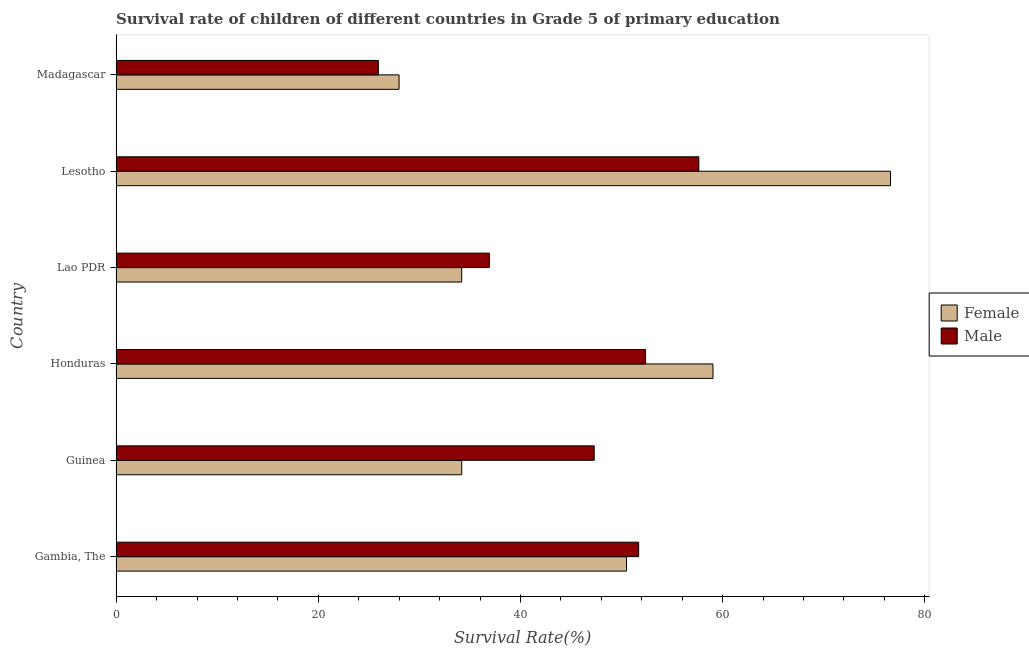How many different coloured bars are there?
Keep it short and to the point. 2. How many groups of bars are there?
Provide a succinct answer. 6. Are the number of bars on each tick of the Y-axis equal?
Give a very brief answer. Yes. What is the label of the 2nd group of bars from the top?
Keep it short and to the point. Lesotho. What is the survival rate of male students in primary education in Guinea?
Make the answer very short. 47.29. Across all countries, what is the maximum survival rate of female students in primary education?
Give a very brief answer. 76.6. Across all countries, what is the minimum survival rate of male students in primary education?
Provide a succinct answer. 25.94. In which country was the survival rate of male students in primary education maximum?
Make the answer very short. Lesotho. In which country was the survival rate of male students in primary education minimum?
Keep it short and to the point. Madagascar. What is the total survival rate of male students in primary education in the graph?
Keep it short and to the point. 271.85. What is the difference between the survival rate of male students in primary education in Gambia, The and that in Guinea?
Offer a terse response. 4.4. What is the difference between the survival rate of male students in primary education in Honduras and the survival rate of female students in primary education in Madagascar?
Ensure brevity in your answer.  24.38. What is the average survival rate of female students in primary education per country?
Offer a very short reply. 47.08. What is the difference between the survival rate of female students in primary education and survival rate of male students in primary education in Madagascar?
Give a very brief answer. 2.05. In how many countries, is the survival rate of male students in primary education greater than 64 %?
Make the answer very short. 0. What is the ratio of the survival rate of male students in primary education in Honduras to that in Madagascar?
Offer a terse response. 2.02. Is the survival rate of female students in primary education in Gambia, The less than that in Lesotho?
Offer a terse response. Yes. What is the difference between the highest and the second highest survival rate of female students in primary education?
Your answer should be compact. 17.56. What is the difference between the highest and the lowest survival rate of male students in primary education?
Provide a short and direct response. 31.7. In how many countries, is the survival rate of female students in primary education greater than the average survival rate of female students in primary education taken over all countries?
Your answer should be compact. 3. Is the sum of the survival rate of male students in primary education in Gambia, The and Guinea greater than the maximum survival rate of female students in primary education across all countries?
Your answer should be very brief. Yes. How many countries are there in the graph?
Offer a terse response. 6. Are the values on the major ticks of X-axis written in scientific E-notation?
Your response must be concise. No. Does the graph contain grids?
Your answer should be compact. No. Where does the legend appear in the graph?
Your answer should be compact. Center right. How many legend labels are there?
Keep it short and to the point. 2. How are the legend labels stacked?
Your answer should be very brief. Vertical. What is the title of the graph?
Your answer should be compact. Survival rate of children of different countries in Grade 5 of primary education. Does "Tetanus" appear as one of the legend labels in the graph?
Give a very brief answer. No. What is the label or title of the X-axis?
Ensure brevity in your answer.  Survival Rate(%). What is the Survival Rate(%) in Female in Gambia, The?
Offer a terse response. 50.49. What is the Survival Rate(%) in Male in Gambia, The?
Give a very brief answer. 51.69. What is the Survival Rate(%) of Female in Guinea?
Your response must be concise. 34.19. What is the Survival Rate(%) of Male in Guinea?
Make the answer very short. 47.29. What is the Survival Rate(%) in Female in Honduras?
Keep it short and to the point. 59.04. What is the Survival Rate(%) of Male in Honduras?
Offer a very short reply. 52.37. What is the Survival Rate(%) in Female in Lao PDR?
Ensure brevity in your answer.  34.18. What is the Survival Rate(%) of Male in Lao PDR?
Your answer should be very brief. 36.92. What is the Survival Rate(%) of Female in Lesotho?
Keep it short and to the point. 76.6. What is the Survival Rate(%) of Male in Lesotho?
Provide a succinct answer. 57.64. What is the Survival Rate(%) of Female in Madagascar?
Your response must be concise. 27.99. What is the Survival Rate(%) of Male in Madagascar?
Make the answer very short. 25.94. Across all countries, what is the maximum Survival Rate(%) of Female?
Your answer should be compact. 76.6. Across all countries, what is the maximum Survival Rate(%) of Male?
Keep it short and to the point. 57.64. Across all countries, what is the minimum Survival Rate(%) in Female?
Your answer should be very brief. 27.99. Across all countries, what is the minimum Survival Rate(%) in Male?
Keep it short and to the point. 25.94. What is the total Survival Rate(%) in Female in the graph?
Make the answer very short. 282.49. What is the total Survival Rate(%) of Male in the graph?
Ensure brevity in your answer.  271.85. What is the difference between the Survival Rate(%) in Female in Gambia, The and that in Guinea?
Your answer should be compact. 16.3. What is the difference between the Survival Rate(%) of Male in Gambia, The and that in Guinea?
Make the answer very short. 4.4. What is the difference between the Survival Rate(%) of Female in Gambia, The and that in Honduras?
Offer a terse response. -8.55. What is the difference between the Survival Rate(%) of Male in Gambia, The and that in Honduras?
Keep it short and to the point. -0.68. What is the difference between the Survival Rate(%) of Female in Gambia, The and that in Lao PDR?
Make the answer very short. 16.31. What is the difference between the Survival Rate(%) of Male in Gambia, The and that in Lao PDR?
Ensure brevity in your answer.  14.77. What is the difference between the Survival Rate(%) of Female in Gambia, The and that in Lesotho?
Your response must be concise. -26.11. What is the difference between the Survival Rate(%) of Male in Gambia, The and that in Lesotho?
Offer a terse response. -5.95. What is the difference between the Survival Rate(%) in Female in Gambia, The and that in Madagascar?
Offer a terse response. 22.5. What is the difference between the Survival Rate(%) in Male in Gambia, The and that in Madagascar?
Ensure brevity in your answer.  25.75. What is the difference between the Survival Rate(%) in Female in Guinea and that in Honduras?
Offer a terse response. -24.85. What is the difference between the Survival Rate(%) in Male in Guinea and that in Honduras?
Provide a short and direct response. -5.08. What is the difference between the Survival Rate(%) in Female in Guinea and that in Lao PDR?
Provide a succinct answer. 0.01. What is the difference between the Survival Rate(%) of Male in Guinea and that in Lao PDR?
Offer a terse response. 10.37. What is the difference between the Survival Rate(%) in Female in Guinea and that in Lesotho?
Offer a terse response. -42.41. What is the difference between the Survival Rate(%) of Male in Guinea and that in Lesotho?
Offer a terse response. -10.35. What is the difference between the Survival Rate(%) of Female in Guinea and that in Madagascar?
Your answer should be compact. 6.2. What is the difference between the Survival Rate(%) in Male in Guinea and that in Madagascar?
Your answer should be very brief. 21.35. What is the difference between the Survival Rate(%) of Female in Honduras and that in Lao PDR?
Your answer should be very brief. 24.86. What is the difference between the Survival Rate(%) of Male in Honduras and that in Lao PDR?
Make the answer very short. 15.45. What is the difference between the Survival Rate(%) of Female in Honduras and that in Lesotho?
Your response must be concise. -17.56. What is the difference between the Survival Rate(%) in Male in Honduras and that in Lesotho?
Give a very brief answer. -5.27. What is the difference between the Survival Rate(%) in Female in Honduras and that in Madagascar?
Offer a very short reply. 31.05. What is the difference between the Survival Rate(%) in Male in Honduras and that in Madagascar?
Your answer should be very brief. 26.43. What is the difference between the Survival Rate(%) in Female in Lao PDR and that in Lesotho?
Your response must be concise. -42.42. What is the difference between the Survival Rate(%) of Male in Lao PDR and that in Lesotho?
Your answer should be very brief. -20.72. What is the difference between the Survival Rate(%) in Female in Lao PDR and that in Madagascar?
Give a very brief answer. 6.19. What is the difference between the Survival Rate(%) in Male in Lao PDR and that in Madagascar?
Your answer should be compact. 10.98. What is the difference between the Survival Rate(%) in Female in Lesotho and that in Madagascar?
Offer a very short reply. 48.61. What is the difference between the Survival Rate(%) of Male in Lesotho and that in Madagascar?
Offer a terse response. 31.7. What is the difference between the Survival Rate(%) in Female in Gambia, The and the Survival Rate(%) in Male in Guinea?
Your answer should be compact. 3.2. What is the difference between the Survival Rate(%) in Female in Gambia, The and the Survival Rate(%) in Male in Honduras?
Ensure brevity in your answer.  -1.88. What is the difference between the Survival Rate(%) of Female in Gambia, The and the Survival Rate(%) of Male in Lao PDR?
Provide a short and direct response. 13.57. What is the difference between the Survival Rate(%) of Female in Gambia, The and the Survival Rate(%) of Male in Lesotho?
Your answer should be compact. -7.15. What is the difference between the Survival Rate(%) of Female in Gambia, The and the Survival Rate(%) of Male in Madagascar?
Ensure brevity in your answer.  24.55. What is the difference between the Survival Rate(%) of Female in Guinea and the Survival Rate(%) of Male in Honduras?
Keep it short and to the point. -18.18. What is the difference between the Survival Rate(%) of Female in Guinea and the Survival Rate(%) of Male in Lao PDR?
Make the answer very short. -2.73. What is the difference between the Survival Rate(%) of Female in Guinea and the Survival Rate(%) of Male in Lesotho?
Your response must be concise. -23.45. What is the difference between the Survival Rate(%) in Female in Guinea and the Survival Rate(%) in Male in Madagascar?
Offer a terse response. 8.25. What is the difference between the Survival Rate(%) of Female in Honduras and the Survival Rate(%) of Male in Lao PDR?
Ensure brevity in your answer.  22.12. What is the difference between the Survival Rate(%) in Female in Honduras and the Survival Rate(%) in Male in Lesotho?
Offer a very short reply. 1.4. What is the difference between the Survival Rate(%) of Female in Honduras and the Survival Rate(%) of Male in Madagascar?
Provide a short and direct response. 33.1. What is the difference between the Survival Rate(%) of Female in Lao PDR and the Survival Rate(%) of Male in Lesotho?
Your answer should be very brief. -23.46. What is the difference between the Survival Rate(%) in Female in Lao PDR and the Survival Rate(%) in Male in Madagascar?
Provide a short and direct response. 8.24. What is the difference between the Survival Rate(%) of Female in Lesotho and the Survival Rate(%) of Male in Madagascar?
Your response must be concise. 50.66. What is the average Survival Rate(%) in Female per country?
Your answer should be compact. 47.08. What is the average Survival Rate(%) in Male per country?
Offer a terse response. 45.31. What is the difference between the Survival Rate(%) of Female and Survival Rate(%) of Male in Gambia, The?
Make the answer very short. -1.2. What is the difference between the Survival Rate(%) in Female and Survival Rate(%) in Male in Guinea?
Offer a terse response. -13.1. What is the difference between the Survival Rate(%) of Female and Survival Rate(%) of Male in Honduras?
Keep it short and to the point. 6.67. What is the difference between the Survival Rate(%) of Female and Survival Rate(%) of Male in Lao PDR?
Offer a very short reply. -2.74. What is the difference between the Survival Rate(%) in Female and Survival Rate(%) in Male in Lesotho?
Offer a terse response. 18.96. What is the difference between the Survival Rate(%) of Female and Survival Rate(%) of Male in Madagascar?
Provide a succinct answer. 2.05. What is the ratio of the Survival Rate(%) of Female in Gambia, The to that in Guinea?
Provide a short and direct response. 1.48. What is the ratio of the Survival Rate(%) in Male in Gambia, The to that in Guinea?
Offer a very short reply. 1.09. What is the ratio of the Survival Rate(%) of Female in Gambia, The to that in Honduras?
Your answer should be compact. 0.86. What is the ratio of the Survival Rate(%) of Male in Gambia, The to that in Honduras?
Ensure brevity in your answer.  0.99. What is the ratio of the Survival Rate(%) in Female in Gambia, The to that in Lao PDR?
Provide a short and direct response. 1.48. What is the ratio of the Survival Rate(%) in Male in Gambia, The to that in Lao PDR?
Offer a very short reply. 1.4. What is the ratio of the Survival Rate(%) in Female in Gambia, The to that in Lesotho?
Offer a terse response. 0.66. What is the ratio of the Survival Rate(%) in Male in Gambia, The to that in Lesotho?
Keep it short and to the point. 0.9. What is the ratio of the Survival Rate(%) of Female in Gambia, The to that in Madagascar?
Make the answer very short. 1.8. What is the ratio of the Survival Rate(%) of Male in Gambia, The to that in Madagascar?
Your response must be concise. 1.99. What is the ratio of the Survival Rate(%) of Female in Guinea to that in Honduras?
Make the answer very short. 0.58. What is the ratio of the Survival Rate(%) of Male in Guinea to that in Honduras?
Your answer should be very brief. 0.9. What is the ratio of the Survival Rate(%) in Male in Guinea to that in Lao PDR?
Offer a very short reply. 1.28. What is the ratio of the Survival Rate(%) of Female in Guinea to that in Lesotho?
Make the answer very short. 0.45. What is the ratio of the Survival Rate(%) of Male in Guinea to that in Lesotho?
Provide a short and direct response. 0.82. What is the ratio of the Survival Rate(%) in Female in Guinea to that in Madagascar?
Provide a short and direct response. 1.22. What is the ratio of the Survival Rate(%) in Male in Guinea to that in Madagascar?
Your answer should be compact. 1.82. What is the ratio of the Survival Rate(%) in Female in Honduras to that in Lao PDR?
Your answer should be very brief. 1.73. What is the ratio of the Survival Rate(%) in Male in Honduras to that in Lao PDR?
Your answer should be very brief. 1.42. What is the ratio of the Survival Rate(%) of Female in Honduras to that in Lesotho?
Make the answer very short. 0.77. What is the ratio of the Survival Rate(%) in Male in Honduras to that in Lesotho?
Keep it short and to the point. 0.91. What is the ratio of the Survival Rate(%) of Female in Honduras to that in Madagascar?
Offer a terse response. 2.11. What is the ratio of the Survival Rate(%) in Male in Honduras to that in Madagascar?
Provide a short and direct response. 2.02. What is the ratio of the Survival Rate(%) in Female in Lao PDR to that in Lesotho?
Ensure brevity in your answer.  0.45. What is the ratio of the Survival Rate(%) of Male in Lao PDR to that in Lesotho?
Keep it short and to the point. 0.64. What is the ratio of the Survival Rate(%) of Female in Lao PDR to that in Madagascar?
Offer a very short reply. 1.22. What is the ratio of the Survival Rate(%) of Male in Lao PDR to that in Madagascar?
Keep it short and to the point. 1.42. What is the ratio of the Survival Rate(%) in Female in Lesotho to that in Madagascar?
Keep it short and to the point. 2.74. What is the ratio of the Survival Rate(%) in Male in Lesotho to that in Madagascar?
Your answer should be compact. 2.22. What is the difference between the highest and the second highest Survival Rate(%) in Female?
Your answer should be compact. 17.56. What is the difference between the highest and the second highest Survival Rate(%) in Male?
Give a very brief answer. 5.27. What is the difference between the highest and the lowest Survival Rate(%) of Female?
Your answer should be compact. 48.61. What is the difference between the highest and the lowest Survival Rate(%) of Male?
Ensure brevity in your answer.  31.7. 